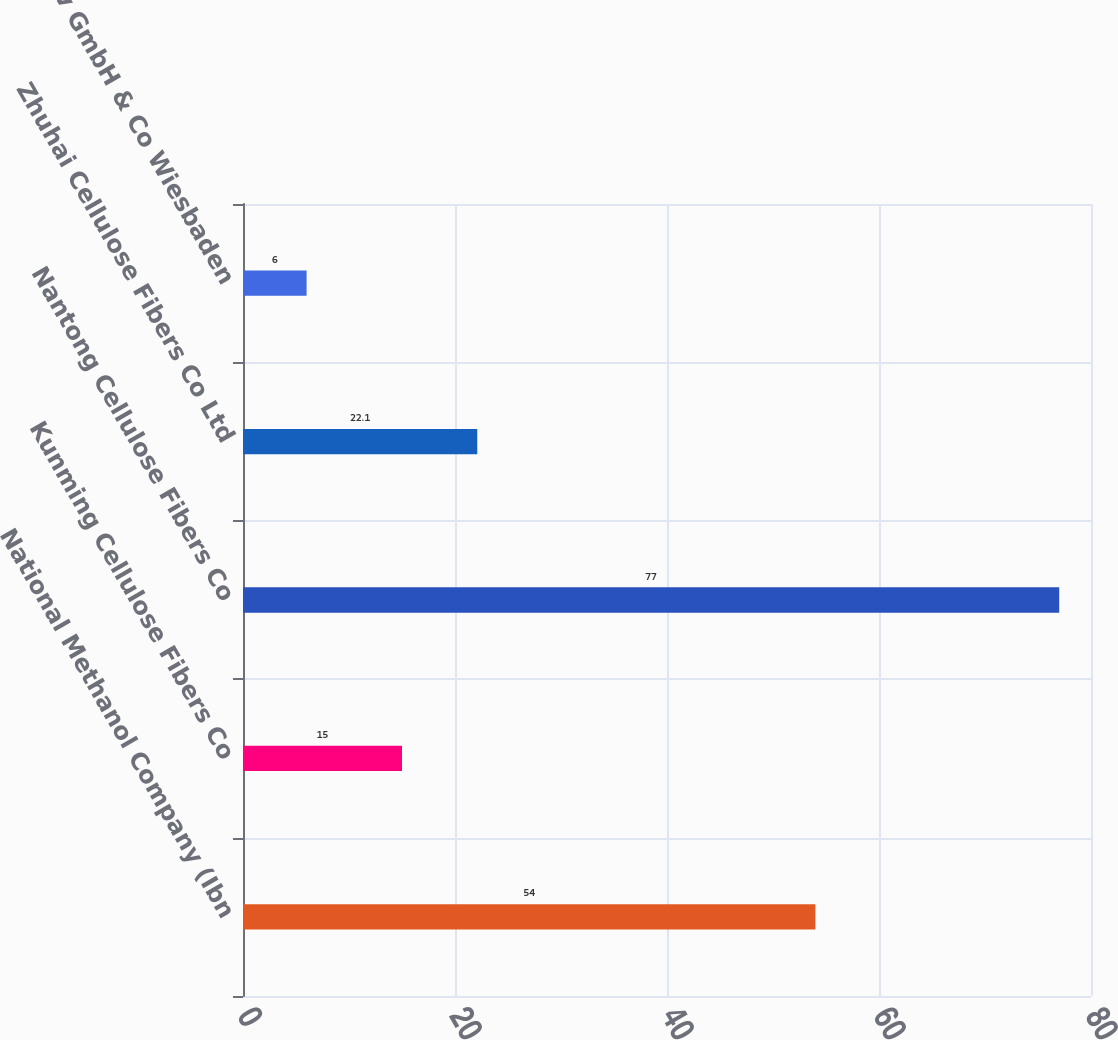Convert chart to OTSL. <chart><loc_0><loc_0><loc_500><loc_500><bar_chart><fcel>National Methanol Company (Ibn<fcel>Kunming Cellulose Fibers Co<fcel>Nantong Cellulose Fibers Co<fcel>Zhuhai Cellulose Fibers Co Ltd<fcel>InfraServ GmbH & Co Wiesbaden<nl><fcel>54<fcel>15<fcel>77<fcel>22.1<fcel>6<nl></chart> 